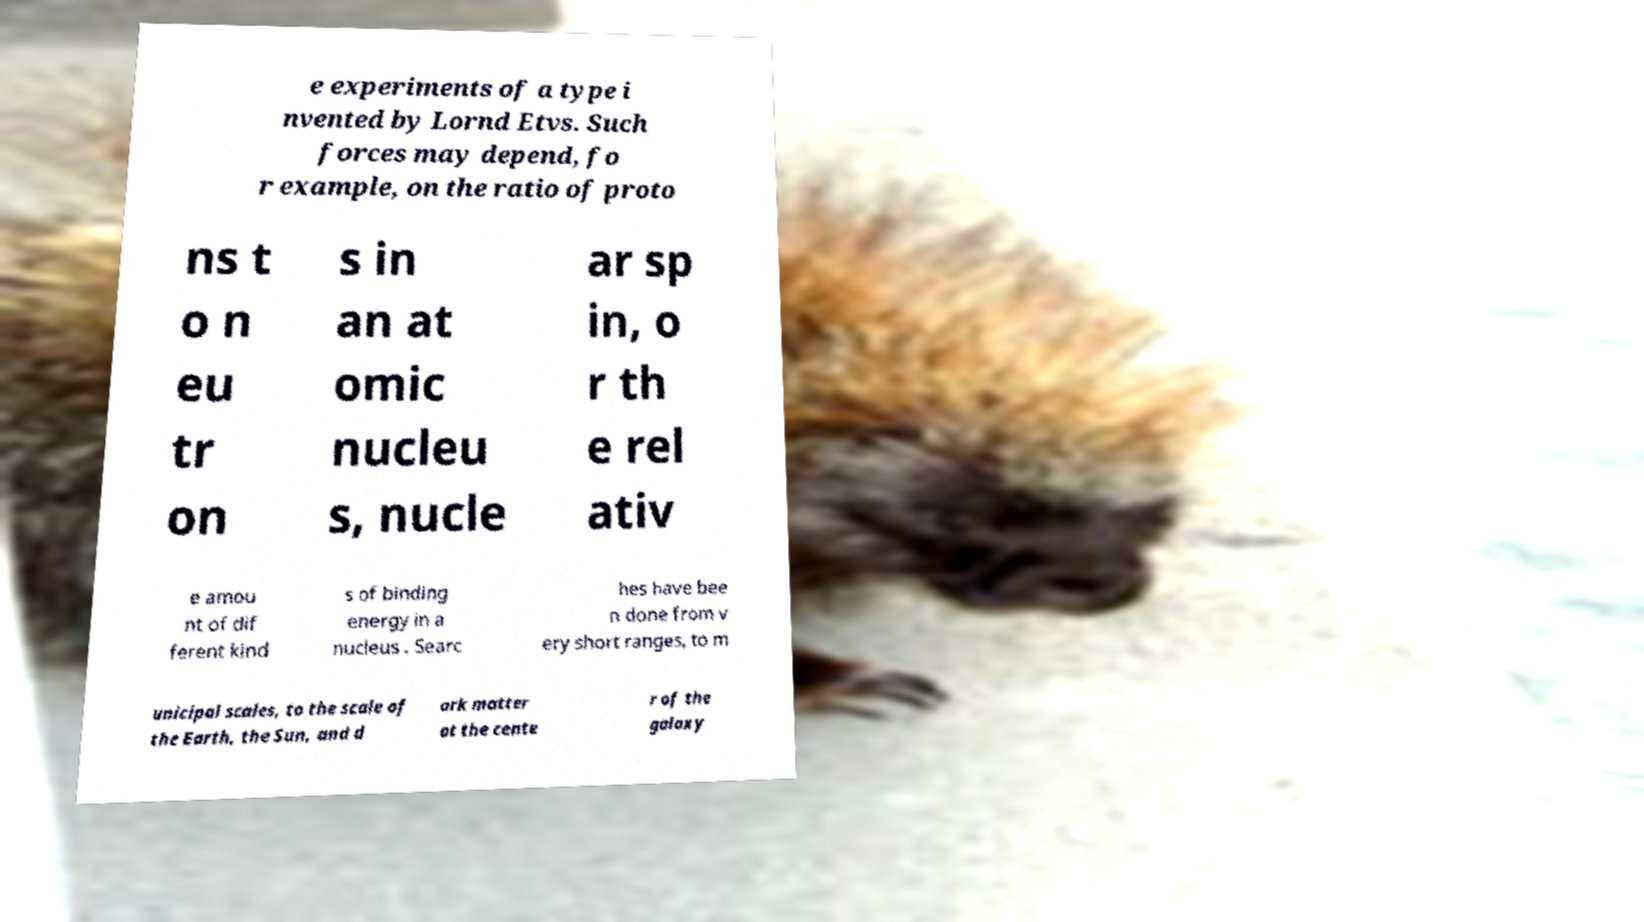Could you extract and type out the text from this image? e experiments of a type i nvented by Lornd Etvs. Such forces may depend, fo r example, on the ratio of proto ns t o n eu tr on s in an at omic nucleu s, nucle ar sp in, o r th e rel ativ e amou nt of dif ferent kind s of binding energy in a nucleus . Searc hes have bee n done from v ery short ranges, to m unicipal scales, to the scale of the Earth, the Sun, and d ark matter at the cente r of the galaxy 